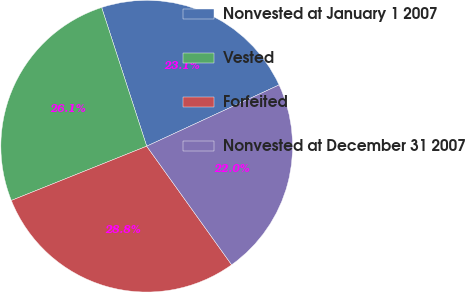<chart> <loc_0><loc_0><loc_500><loc_500><pie_chart><fcel>Nonvested at January 1 2007<fcel>Vested<fcel>Forfeited<fcel>Nonvested at December 31 2007<nl><fcel>23.1%<fcel>26.07%<fcel>28.82%<fcel>22.01%<nl></chart> 